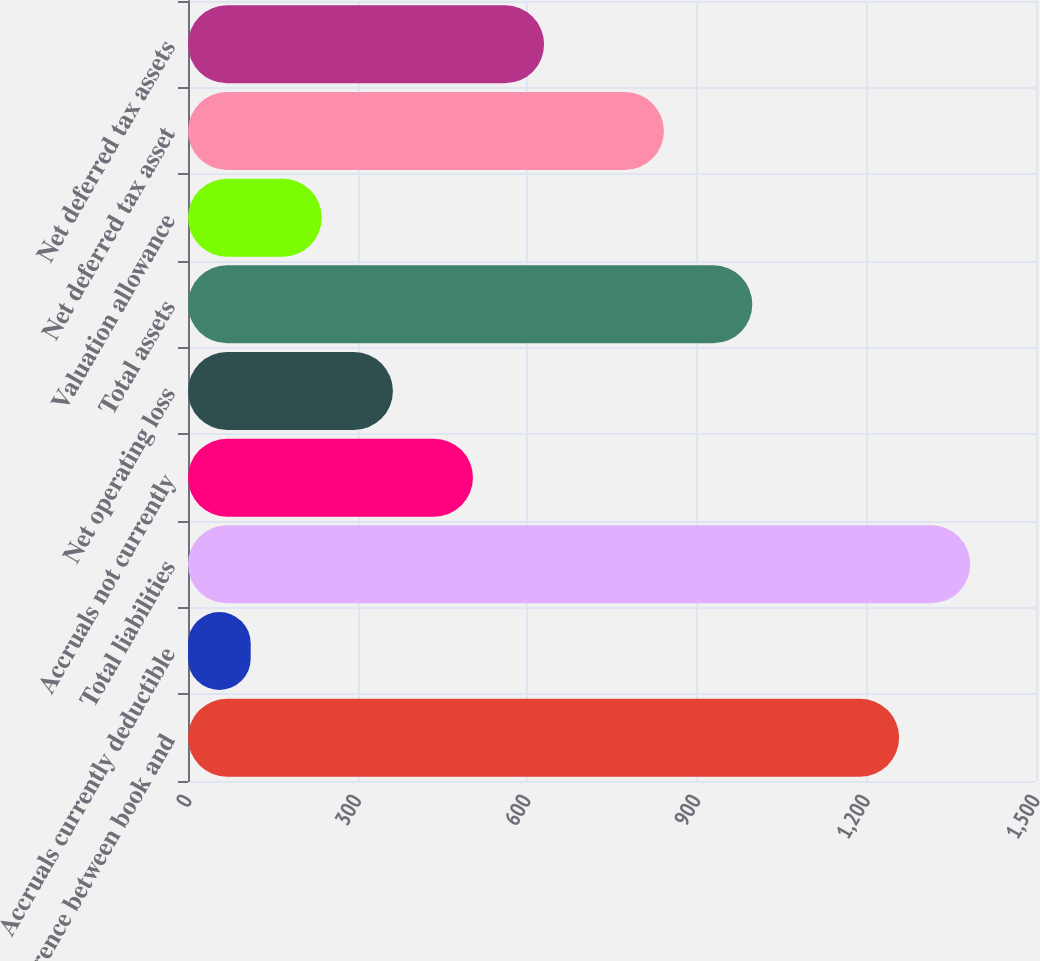<chart> <loc_0><loc_0><loc_500><loc_500><bar_chart><fcel>Difference between book and<fcel>Accruals currently deductible<fcel>Total liabilities<fcel>Accruals not currently<fcel>Net operating loss<fcel>Total assets<fcel>Valuation allowance<fcel>Net deferred tax asset<fcel>Net deferred tax assets<nl><fcel>1257.9<fcel>110.9<fcel>1383.69<fcel>504.1<fcel>362.48<fcel>998.2<fcel>236.69<fcel>841.8<fcel>629.89<nl></chart> 